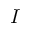<formula> <loc_0><loc_0><loc_500><loc_500>I</formula> 